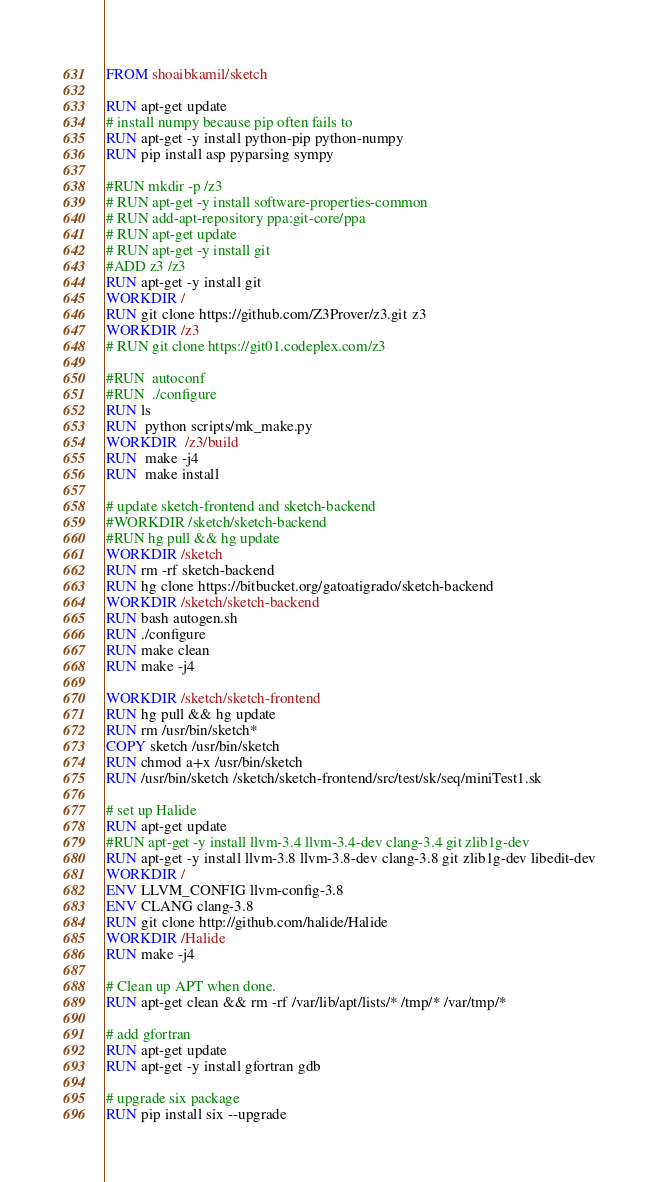Convert code to text. <code><loc_0><loc_0><loc_500><loc_500><_Dockerfile_>FROM shoaibkamil/sketch

RUN apt-get update
# install numpy because pip often fails to
RUN apt-get -y install python-pip python-numpy
RUN pip install asp pyparsing sympy

#RUN mkdir -p /z3
# RUN apt-get -y install software-properties-common
# RUN add-apt-repository ppa:git-core/ppa
# RUN apt-get update
# RUN apt-get -y install git
#ADD z3 /z3
RUN apt-get -y install git
WORKDIR /
RUN git clone https://github.com/Z3Prover/z3.git z3
WORKDIR /z3
# RUN git clone https://git01.codeplex.com/z3

#RUN  autoconf
#RUN  ./configure
RUN ls
RUN  python scripts/mk_make.py
WORKDIR  /z3/build
RUN  make -j4
RUN  make install

# update sketch-frontend and sketch-backend
#WORKDIR /sketch/sketch-backend
#RUN hg pull && hg update
WORKDIR /sketch
RUN rm -rf sketch-backend
RUN hg clone https://bitbucket.org/gatoatigrado/sketch-backend
WORKDIR /sketch/sketch-backend
RUN bash autogen.sh
RUN ./configure
RUN make clean
RUN make -j4

WORKDIR /sketch/sketch-frontend
RUN hg pull && hg update
RUN rm /usr/bin/sketch*
COPY sketch /usr/bin/sketch
RUN chmod a+x /usr/bin/sketch
RUN /usr/bin/sketch /sketch/sketch-frontend/src/test/sk/seq/miniTest1.sk

# set up Halide
RUN apt-get update
#RUN apt-get -y install llvm-3.4 llvm-3.4-dev clang-3.4 git zlib1g-dev
RUN apt-get -y install llvm-3.8 llvm-3.8-dev clang-3.8 git zlib1g-dev libedit-dev
WORKDIR /
ENV LLVM_CONFIG llvm-config-3.8
ENV CLANG clang-3.8
RUN git clone http://github.com/halide/Halide
WORKDIR /Halide
RUN make -j4

# Clean up APT when done.
RUN apt-get clean && rm -rf /var/lib/apt/lists/* /tmp/* /var/tmp/*

# add gfortran
RUN apt-get update
RUN apt-get -y install gfortran gdb

# upgrade six package
RUN pip install six --upgrade
</code> 